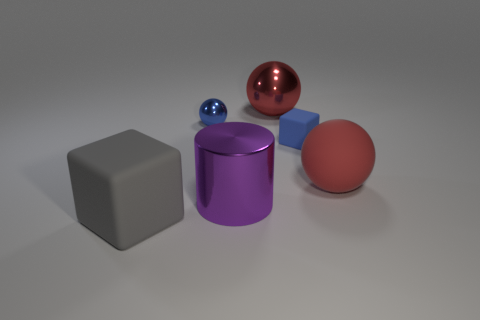Subtract all red balls. How many were subtracted if there are1red balls left? 1 Subtract all big metal spheres. How many spheres are left? 2 Subtract all brown cylinders. How many red balls are left? 2 Add 2 tiny red shiny cubes. How many objects exist? 8 Subtract all cylinders. How many objects are left? 5 Subtract 1 spheres. How many spheres are left? 2 Add 6 matte balls. How many matte balls are left? 7 Add 3 green spheres. How many green spheres exist? 3 Subtract 1 purple cylinders. How many objects are left? 5 Subtract all brown cylinders. Subtract all cyan balls. How many cylinders are left? 1 